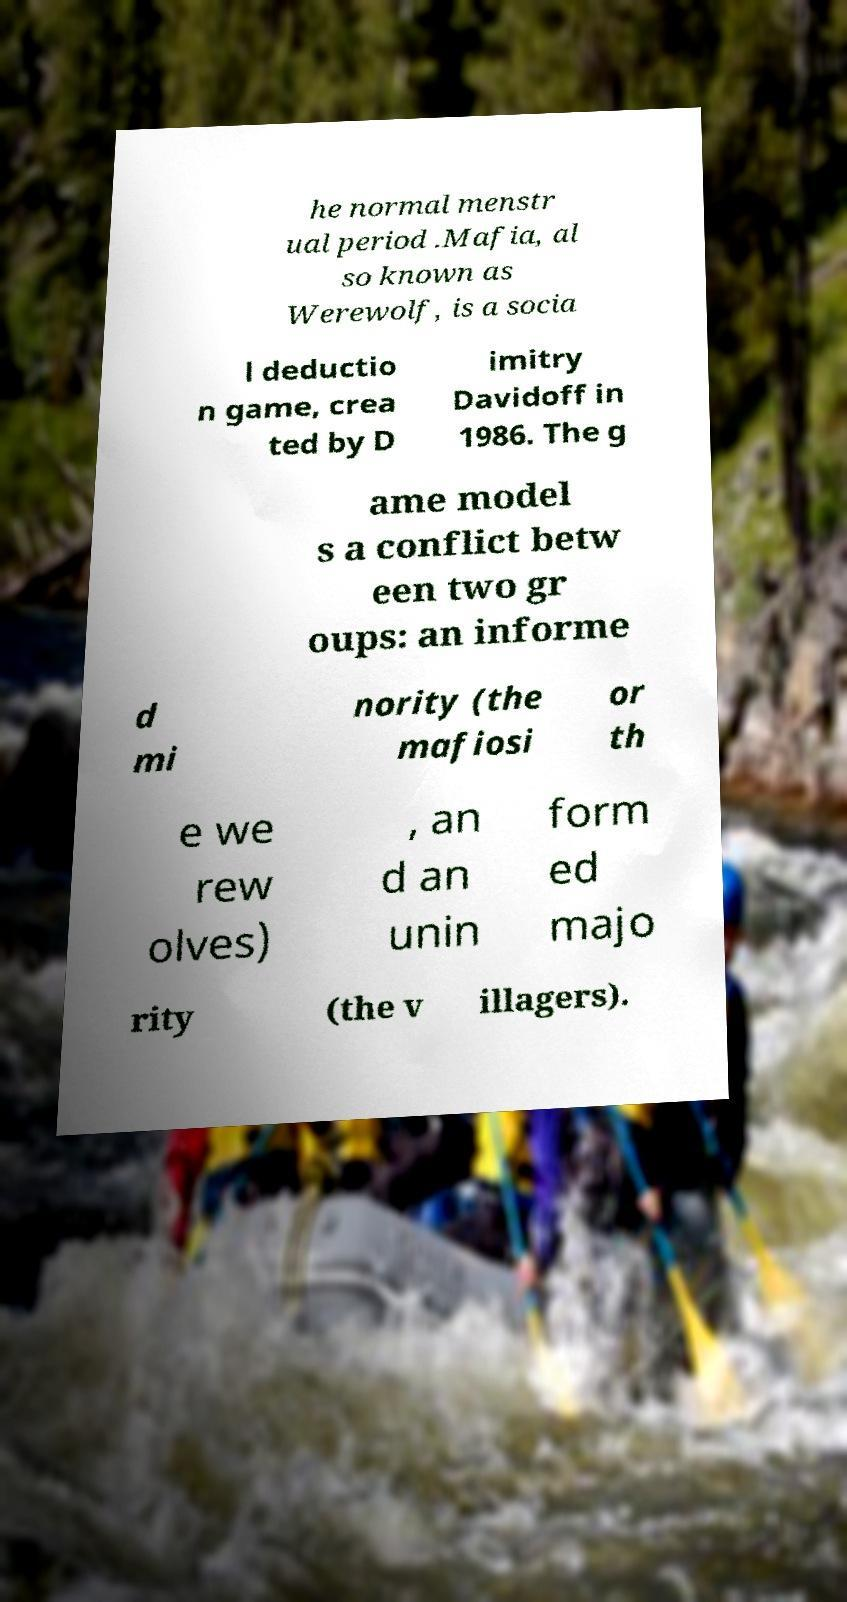Please identify and transcribe the text found in this image. he normal menstr ual period .Mafia, al so known as Werewolf, is a socia l deductio n game, crea ted by D imitry Davidoff in 1986. The g ame model s a conflict betw een two gr oups: an informe d mi nority (the mafiosi or th e we rew olves) , an d an unin form ed majo rity (the v illagers). 